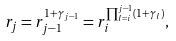Convert formula to latex. <formula><loc_0><loc_0><loc_500><loc_500>r _ { j } = r ^ { 1 + \gamma _ { j - 1 } } _ { j - 1 } = r ^ { \prod ^ { j - 1 } _ { l = i } ( 1 + \gamma _ { l } ) } _ { i } ,</formula> 